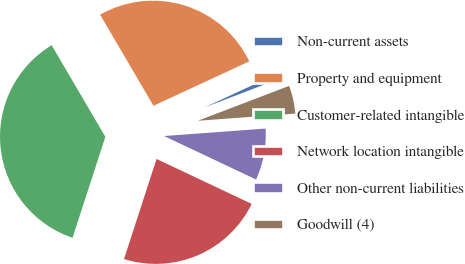<chart> <loc_0><loc_0><loc_500><loc_500><pie_chart><fcel>Non-current assets<fcel>Property and equipment<fcel>Customer-related intangible<fcel>Network location intangible<fcel>Other non-current liabilities<fcel>Goodwill (4)<nl><fcel>1.1%<fcel>26.53%<fcel>36.56%<fcel>22.98%<fcel>8.19%<fcel>4.64%<nl></chart> 